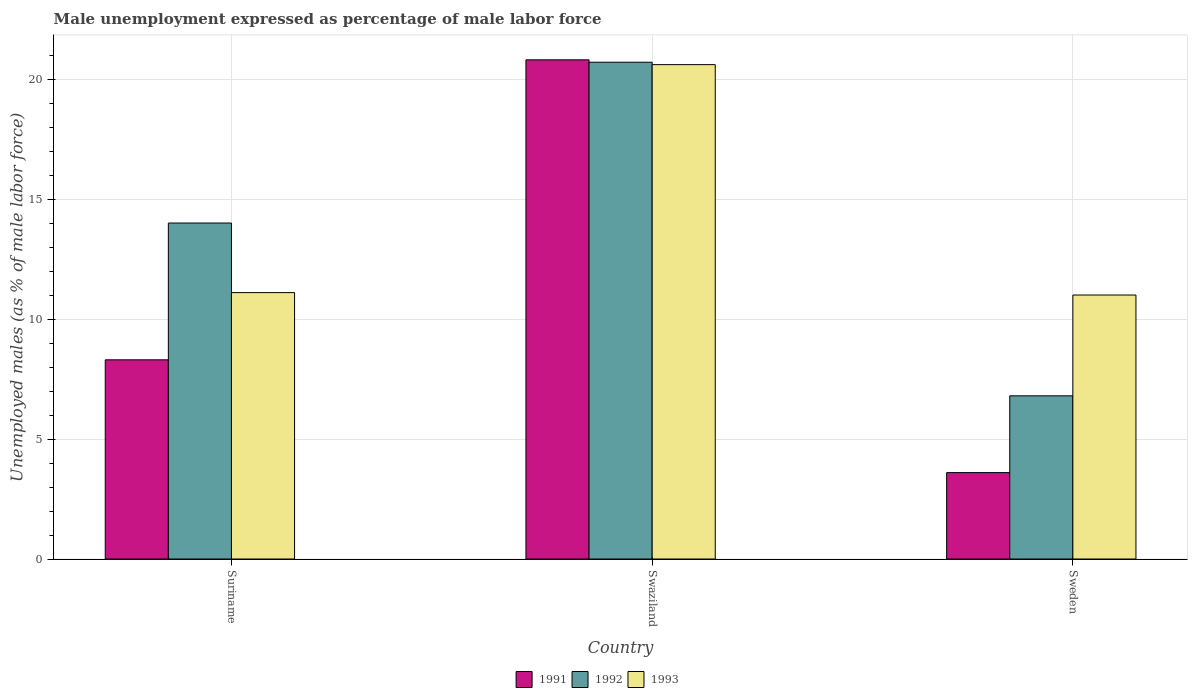How many groups of bars are there?
Provide a short and direct response. 3. How many bars are there on the 1st tick from the right?
Provide a succinct answer. 3. What is the label of the 2nd group of bars from the left?
Your response must be concise. Swaziland. In how many cases, is the number of bars for a given country not equal to the number of legend labels?
Provide a short and direct response. 0. What is the unemployment in males in in 1991 in Swaziland?
Your response must be concise. 20.8. Across all countries, what is the maximum unemployment in males in in 1992?
Keep it short and to the point. 20.7. Across all countries, what is the minimum unemployment in males in in 1993?
Keep it short and to the point. 11. In which country was the unemployment in males in in 1992 maximum?
Keep it short and to the point. Swaziland. In which country was the unemployment in males in in 1991 minimum?
Offer a very short reply. Sweden. What is the total unemployment in males in in 1991 in the graph?
Offer a very short reply. 32.7. What is the difference between the unemployment in males in in 1993 in Suriname and that in Sweden?
Give a very brief answer. 0.1. What is the difference between the unemployment in males in in 1992 in Suriname and the unemployment in males in in 1991 in Sweden?
Keep it short and to the point. 10.4. What is the average unemployment in males in in 1993 per country?
Offer a very short reply. 14.23. What is the difference between the unemployment in males in of/in 1992 and unemployment in males in of/in 1993 in Suriname?
Your answer should be compact. 2.9. What is the ratio of the unemployment in males in in 1993 in Suriname to that in Swaziland?
Provide a short and direct response. 0.54. Is the unemployment in males in in 1991 in Swaziland less than that in Sweden?
Make the answer very short. No. Is the difference between the unemployment in males in in 1992 in Suriname and Swaziland greater than the difference between the unemployment in males in in 1993 in Suriname and Swaziland?
Make the answer very short. Yes. What is the difference between the highest and the second highest unemployment in males in in 1993?
Offer a very short reply. -0.1. What is the difference between the highest and the lowest unemployment in males in in 1992?
Your answer should be compact. 13.9. In how many countries, is the unemployment in males in in 1991 greater than the average unemployment in males in in 1991 taken over all countries?
Offer a terse response. 1. Is the sum of the unemployment in males in in 1993 in Suriname and Swaziland greater than the maximum unemployment in males in in 1991 across all countries?
Provide a succinct answer. Yes. What does the 3rd bar from the left in Sweden represents?
Offer a very short reply. 1993. What does the 3rd bar from the right in Swaziland represents?
Ensure brevity in your answer.  1991. Is it the case that in every country, the sum of the unemployment in males in in 1992 and unemployment in males in in 1993 is greater than the unemployment in males in in 1991?
Offer a terse response. Yes. How many bars are there?
Give a very brief answer. 9. Are all the bars in the graph horizontal?
Provide a short and direct response. No. How many countries are there in the graph?
Your answer should be very brief. 3. What is the difference between two consecutive major ticks on the Y-axis?
Ensure brevity in your answer.  5. Are the values on the major ticks of Y-axis written in scientific E-notation?
Provide a short and direct response. No. Does the graph contain grids?
Provide a succinct answer. Yes. How many legend labels are there?
Your response must be concise. 3. How are the legend labels stacked?
Your answer should be compact. Horizontal. What is the title of the graph?
Offer a very short reply. Male unemployment expressed as percentage of male labor force. Does "1962" appear as one of the legend labels in the graph?
Your answer should be very brief. No. What is the label or title of the X-axis?
Keep it short and to the point. Country. What is the label or title of the Y-axis?
Your response must be concise. Unemployed males (as % of male labor force). What is the Unemployed males (as % of male labor force) in 1991 in Suriname?
Give a very brief answer. 8.3. What is the Unemployed males (as % of male labor force) in 1993 in Suriname?
Keep it short and to the point. 11.1. What is the Unemployed males (as % of male labor force) of 1991 in Swaziland?
Your response must be concise. 20.8. What is the Unemployed males (as % of male labor force) of 1992 in Swaziland?
Provide a short and direct response. 20.7. What is the Unemployed males (as % of male labor force) in 1993 in Swaziland?
Provide a succinct answer. 20.6. What is the Unemployed males (as % of male labor force) in 1991 in Sweden?
Provide a succinct answer. 3.6. What is the Unemployed males (as % of male labor force) in 1992 in Sweden?
Offer a terse response. 6.8. What is the Unemployed males (as % of male labor force) of 1993 in Sweden?
Offer a very short reply. 11. Across all countries, what is the maximum Unemployed males (as % of male labor force) in 1991?
Provide a succinct answer. 20.8. Across all countries, what is the maximum Unemployed males (as % of male labor force) in 1992?
Offer a very short reply. 20.7. Across all countries, what is the maximum Unemployed males (as % of male labor force) of 1993?
Ensure brevity in your answer.  20.6. Across all countries, what is the minimum Unemployed males (as % of male labor force) in 1991?
Your response must be concise. 3.6. Across all countries, what is the minimum Unemployed males (as % of male labor force) of 1992?
Ensure brevity in your answer.  6.8. What is the total Unemployed males (as % of male labor force) in 1991 in the graph?
Offer a terse response. 32.7. What is the total Unemployed males (as % of male labor force) of 1992 in the graph?
Make the answer very short. 41.5. What is the total Unemployed males (as % of male labor force) of 1993 in the graph?
Provide a short and direct response. 42.7. What is the difference between the Unemployed males (as % of male labor force) in 1991 in Suriname and that in Swaziland?
Your answer should be compact. -12.5. What is the difference between the Unemployed males (as % of male labor force) in 1992 in Suriname and that in Swaziland?
Your response must be concise. -6.7. What is the difference between the Unemployed males (as % of male labor force) of 1993 in Suriname and that in Swaziland?
Your answer should be very brief. -9.5. What is the difference between the Unemployed males (as % of male labor force) of 1991 in Suriname and that in Sweden?
Provide a succinct answer. 4.7. What is the difference between the Unemployed males (as % of male labor force) of 1992 in Suriname and that in Sweden?
Give a very brief answer. 7.2. What is the difference between the Unemployed males (as % of male labor force) of 1991 in Swaziland and that in Sweden?
Provide a short and direct response. 17.2. What is the difference between the Unemployed males (as % of male labor force) of 1992 in Swaziland and that in Sweden?
Your answer should be compact. 13.9. What is the difference between the Unemployed males (as % of male labor force) in 1991 in Suriname and the Unemployed males (as % of male labor force) in 1992 in Swaziland?
Your response must be concise. -12.4. What is the difference between the Unemployed males (as % of male labor force) of 1992 in Suriname and the Unemployed males (as % of male labor force) of 1993 in Swaziland?
Give a very brief answer. -6.6. What is the difference between the Unemployed males (as % of male labor force) in 1991 in Suriname and the Unemployed males (as % of male labor force) in 1993 in Sweden?
Your answer should be compact. -2.7. What is the difference between the Unemployed males (as % of male labor force) in 1991 in Swaziland and the Unemployed males (as % of male labor force) in 1992 in Sweden?
Provide a short and direct response. 14. What is the difference between the Unemployed males (as % of male labor force) in 1992 in Swaziland and the Unemployed males (as % of male labor force) in 1993 in Sweden?
Provide a short and direct response. 9.7. What is the average Unemployed males (as % of male labor force) of 1992 per country?
Keep it short and to the point. 13.83. What is the average Unemployed males (as % of male labor force) of 1993 per country?
Keep it short and to the point. 14.23. What is the difference between the Unemployed males (as % of male labor force) in 1991 and Unemployed males (as % of male labor force) in 1992 in Suriname?
Offer a terse response. -5.7. What is the difference between the Unemployed males (as % of male labor force) of 1992 and Unemployed males (as % of male labor force) of 1993 in Suriname?
Your answer should be compact. 2.9. What is the difference between the Unemployed males (as % of male labor force) of 1991 and Unemployed males (as % of male labor force) of 1992 in Swaziland?
Offer a very short reply. 0.1. What is the difference between the Unemployed males (as % of male labor force) in 1991 and Unemployed males (as % of male labor force) in 1992 in Sweden?
Provide a short and direct response. -3.2. What is the difference between the Unemployed males (as % of male labor force) in 1991 and Unemployed males (as % of male labor force) in 1993 in Sweden?
Offer a terse response. -7.4. What is the difference between the Unemployed males (as % of male labor force) of 1992 and Unemployed males (as % of male labor force) of 1993 in Sweden?
Ensure brevity in your answer.  -4.2. What is the ratio of the Unemployed males (as % of male labor force) in 1991 in Suriname to that in Swaziland?
Your answer should be very brief. 0.4. What is the ratio of the Unemployed males (as % of male labor force) in 1992 in Suriname to that in Swaziland?
Give a very brief answer. 0.68. What is the ratio of the Unemployed males (as % of male labor force) in 1993 in Suriname to that in Swaziland?
Provide a succinct answer. 0.54. What is the ratio of the Unemployed males (as % of male labor force) of 1991 in Suriname to that in Sweden?
Provide a succinct answer. 2.31. What is the ratio of the Unemployed males (as % of male labor force) of 1992 in Suriname to that in Sweden?
Your answer should be very brief. 2.06. What is the ratio of the Unemployed males (as % of male labor force) of 1993 in Suriname to that in Sweden?
Ensure brevity in your answer.  1.01. What is the ratio of the Unemployed males (as % of male labor force) in 1991 in Swaziland to that in Sweden?
Give a very brief answer. 5.78. What is the ratio of the Unemployed males (as % of male labor force) of 1992 in Swaziland to that in Sweden?
Your answer should be compact. 3.04. What is the ratio of the Unemployed males (as % of male labor force) of 1993 in Swaziland to that in Sweden?
Your answer should be compact. 1.87. What is the difference between the highest and the second highest Unemployed males (as % of male labor force) of 1993?
Offer a terse response. 9.5. What is the difference between the highest and the lowest Unemployed males (as % of male labor force) of 1991?
Ensure brevity in your answer.  17.2. What is the difference between the highest and the lowest Unemployed males (as % of male labor force) in 1992?
Offer a terse response. 13.9. 